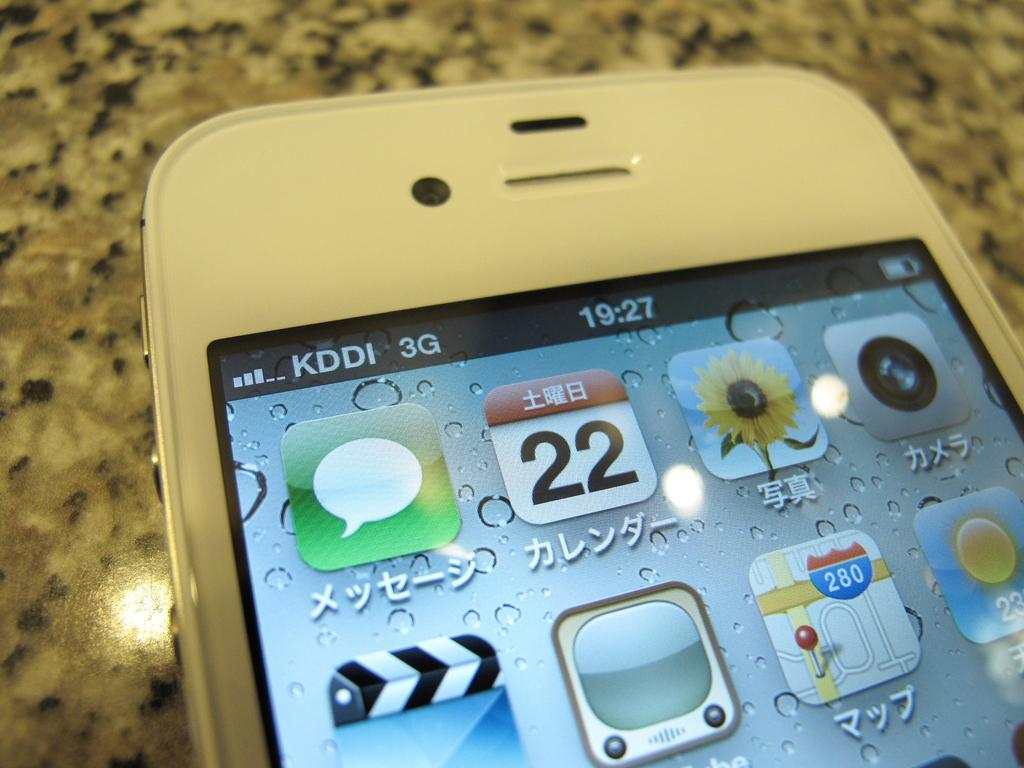<image>
Provide a brief description of the given image. The time of day on a cellphone display reads 19:27 and the date is the 22nd. 